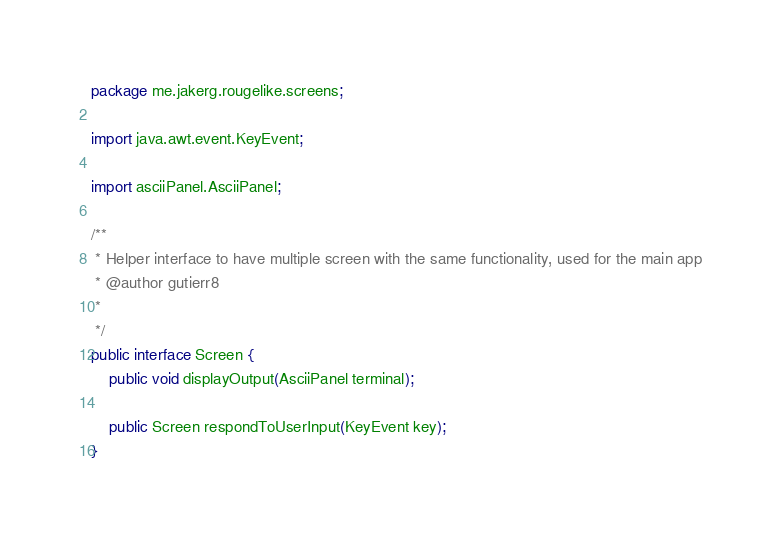<code> <loc_0><loc_0><loc_500><loc_500><_Java_>package me.jakerg.rougelike.screens;

import java.awt.event.KeyEvent;

import asciiPanel.AsciiPanel;

/**
 * Helper interface to have multiple screen with the same functionality, used for the main app
 * @author gutierr8
 *
 */
public interface Screen {
	public void displayOutput(AsciiPanel terminal);
	
	public Screen respondToUserInput(KeyEvent key);
}
</code> 